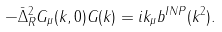<formula> <loc_0><loc_0><loc_500><loc_500>- \bar { \Delta } ^ { 2 } _ { R } G _ { \mu } ( k , 0 ) G ( k ) = i k _ { \mu } b ^ { I N P } ( k ^ { 2 } ) .</formula> 